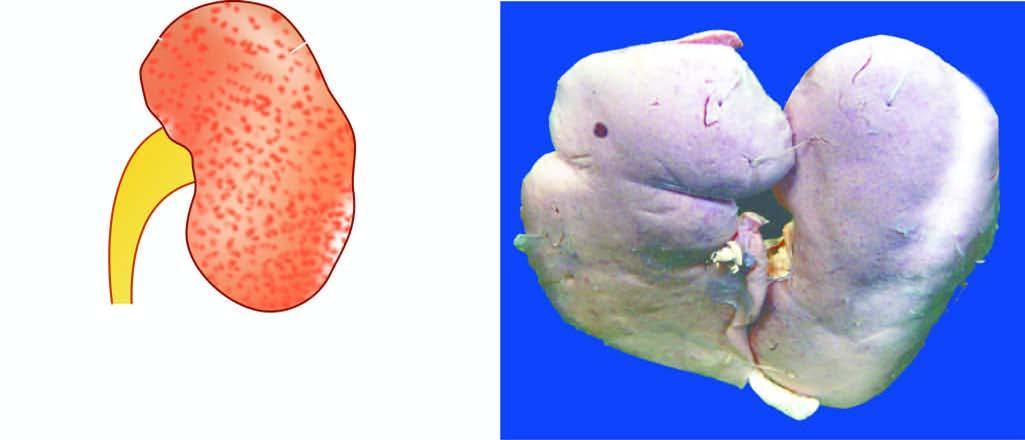what is small and contracted?
Answer the question using a single word or phrase. Kidney 